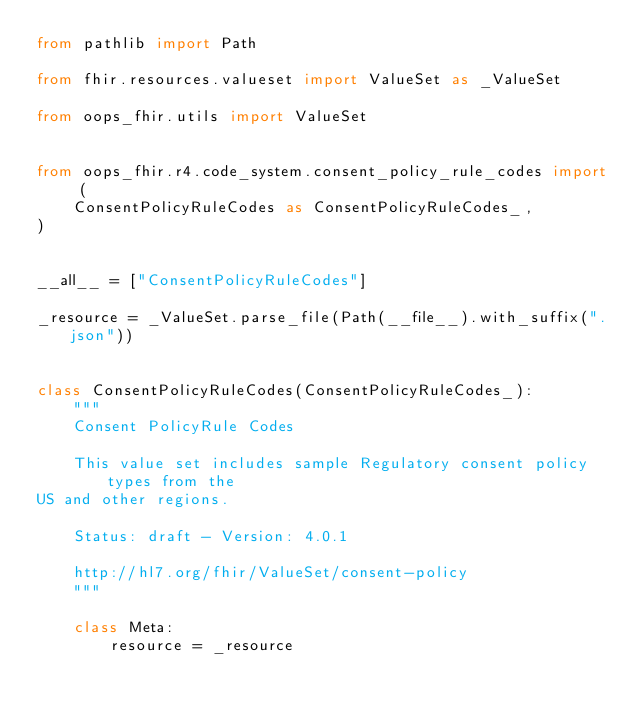Convert code to text. <code><loc_0><loc_0><loc_500><loc_500><_Python_>from pathlib import Path

from fhir.resources.valueset import ValueSet as _ValueSet

from oops_fhir.utils import ValueSet


from oops_fhir.r4.code_system.consent_policy_rule_codes import (
    ConsentPolicyRuleCodes as ConsentPolicyRuleCodes_,
)


__all__ = ["ConsentPolicyRuleCodes"]

_resource = _ValueSet.parse_file(Path(__file__).with_suffix(".json"))


class ConsentPolicyRuleCodes(ConsentPolicyRuleCodes_):
    """
    Consent PolicyRule Codes

    This value set includes sample Regulatory consent policy types from the
US and other regions.

    Status: draft - Version: 4.0.1

    http://hl7.org/fhir/ValueSet/consent-policy
    """

    class Meta:
        resource = _resource
</code> 